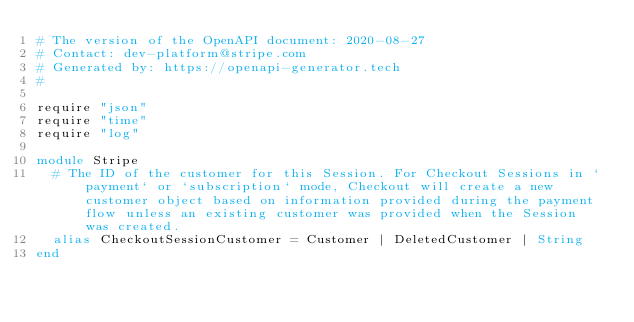Convert code to text. <code><loc_0><loc_0><loc_500><loc_500><_Crystal_># The version of the OpenAPI document: 2020-08-27
# Contact: dev-platform@stripe.com
# Generated by: https://openapi-generator.tech
#

require "json"
require "time"
require "log"

module Stripe
  # The ID of the customer for this Session. For Checkout Sessions in `payment` or `subscription` mode, Checkout will create a new customer object based on information provided during the payment flow unless an existing customer was provided when the Session was created.
  alias CheckoutSessionCustomer = Customer | DeletedCustomer | String
end
</code> 